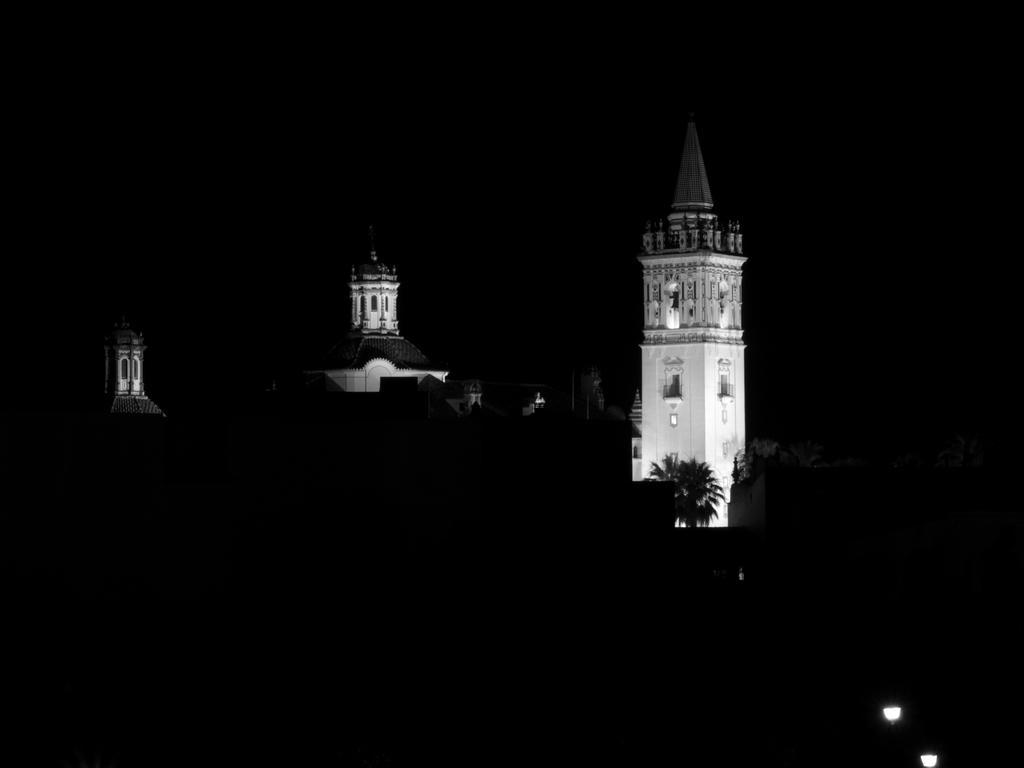Can you describe this image briefly? This looks like a black and white image. These are the buildings. I can see a tree. At the bottom of the image, these look like the lamp lights. This is a spire, which is at the top of a building. The background looks dark. 